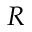<formula> <loc_0><loc_0><loc_500><loc_500>R</formula> 